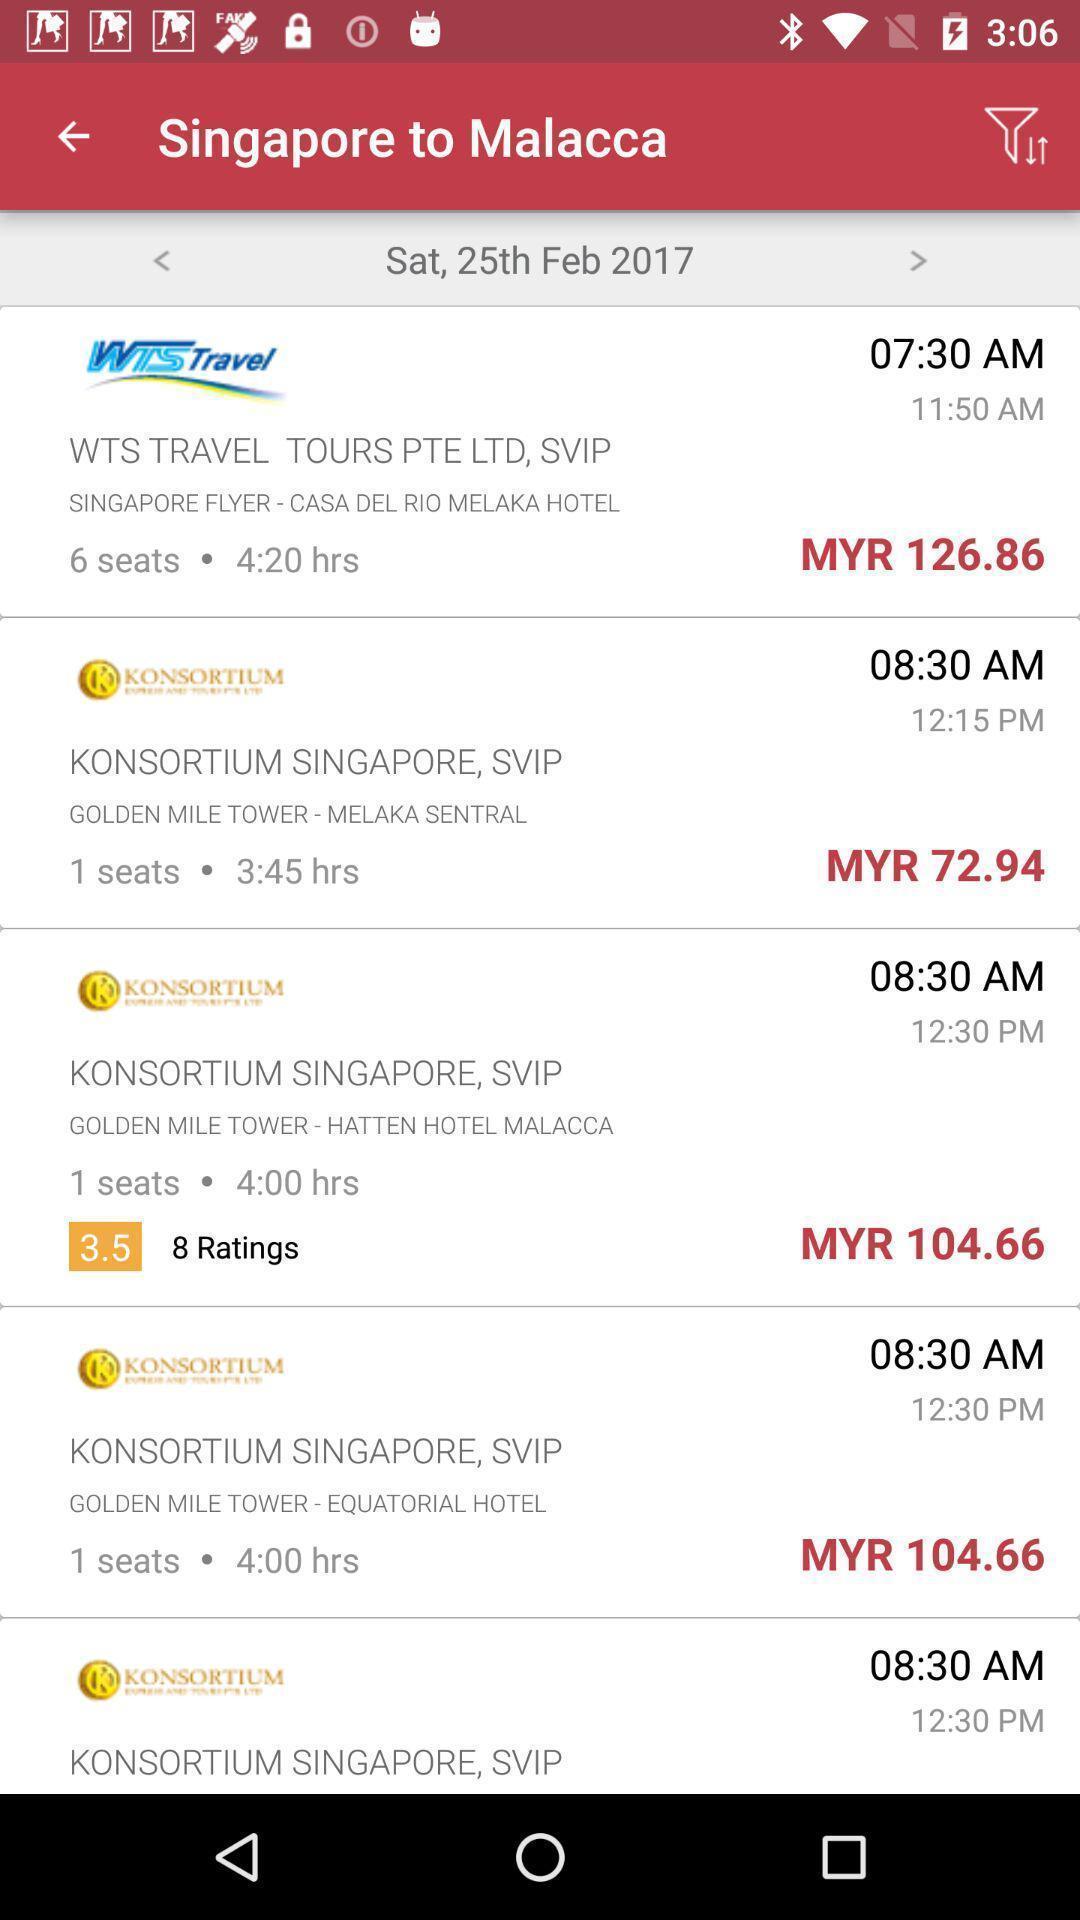Give me a summary of this screen capture. Screen shows travel cost details in a travel pp. 